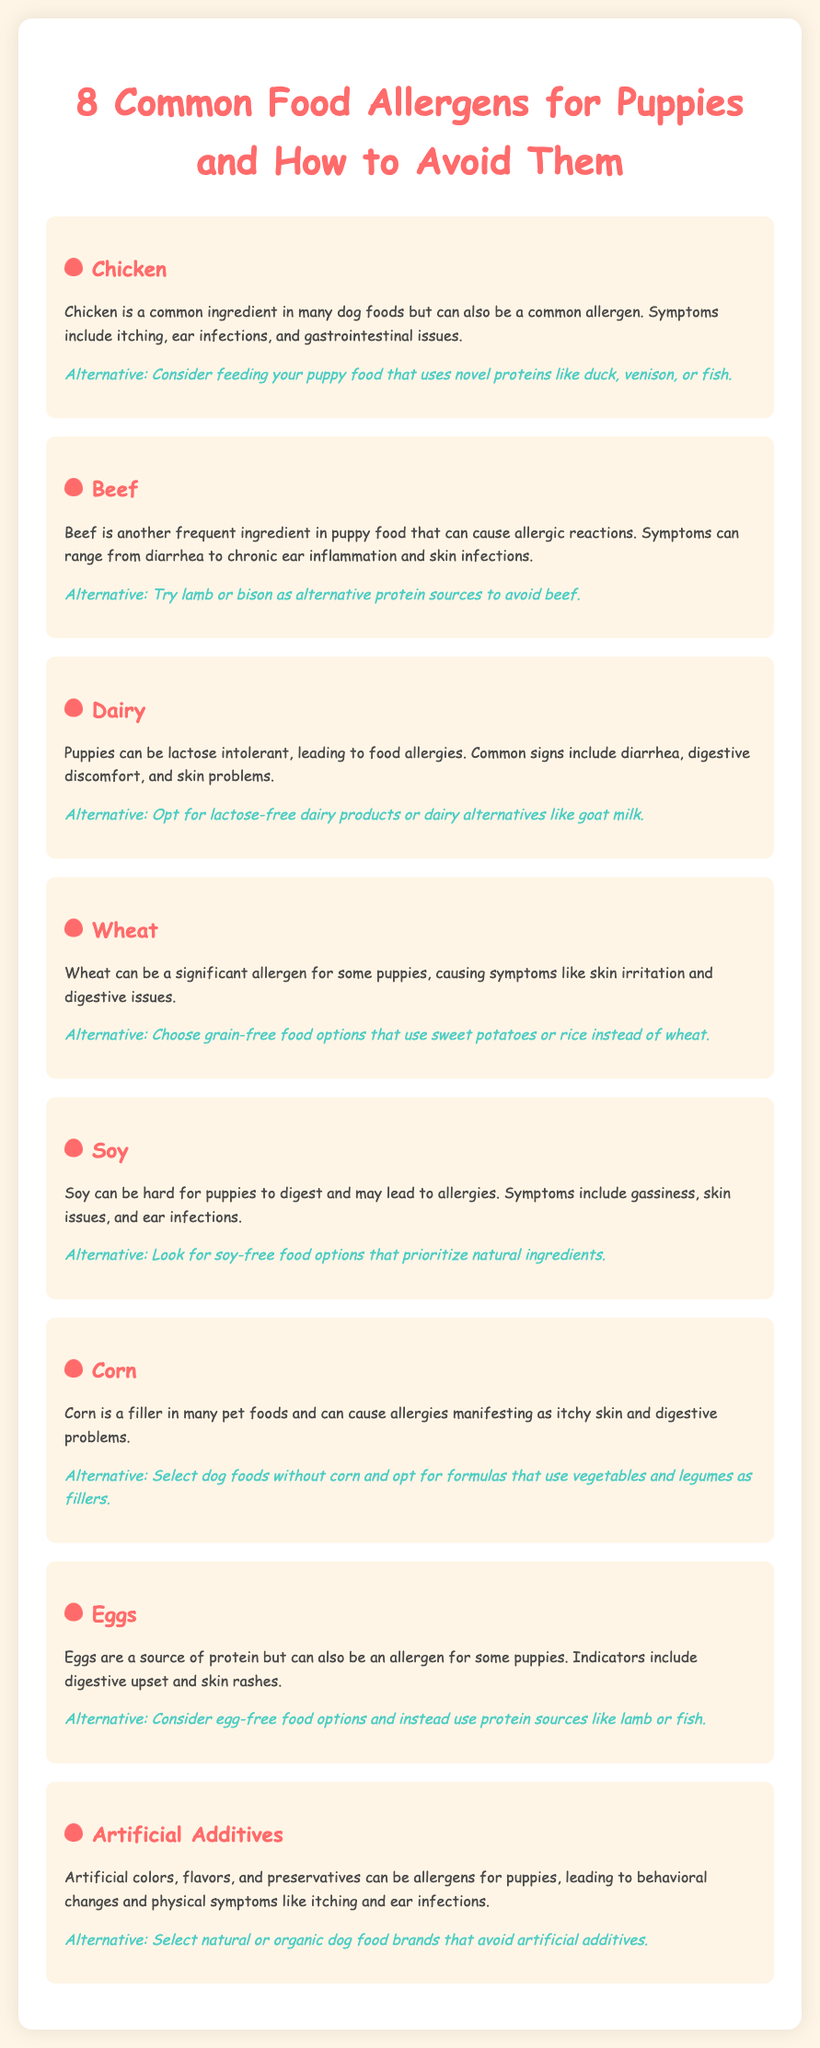what is one common food allergen for puppies? The document lists chicken as a common food allergen for puppies.
Answer: chicken what symptom is associated with beef allergies? The document states that one symptom of beef allergies can be diarrhea.
Answer: diarrhea what alternative is suggested for a puppy allergic to wheat? The document recommends choosing grain-free food that uses sweet potatoes or rice instead of wheat.
Answer: sweet potatoes or rice how many common food allergens are listed for puppies? The document lists a total of eight common food allergens for puppies.
Answer: eight which allergen is associated with artificial colors and preservatives? The document identifies artificial additives as allergens related to artificial colors and preservatives.
Answer: artificial additives what alternative protein source can be used instead of eggs? The document suggests using lamb or fish as an alternative protein source instead of eggs.
Answer: lamb or fish what is a symptom of corn allergies in puppies? According to the document, a symptom of corn allergies includes itchy skin.
Answer: itchy skin what type of food should be avoided for puppies with soy allergies? The document advises looking for soy-free food options to avoid soy allergies.
Answer: soy-free food 